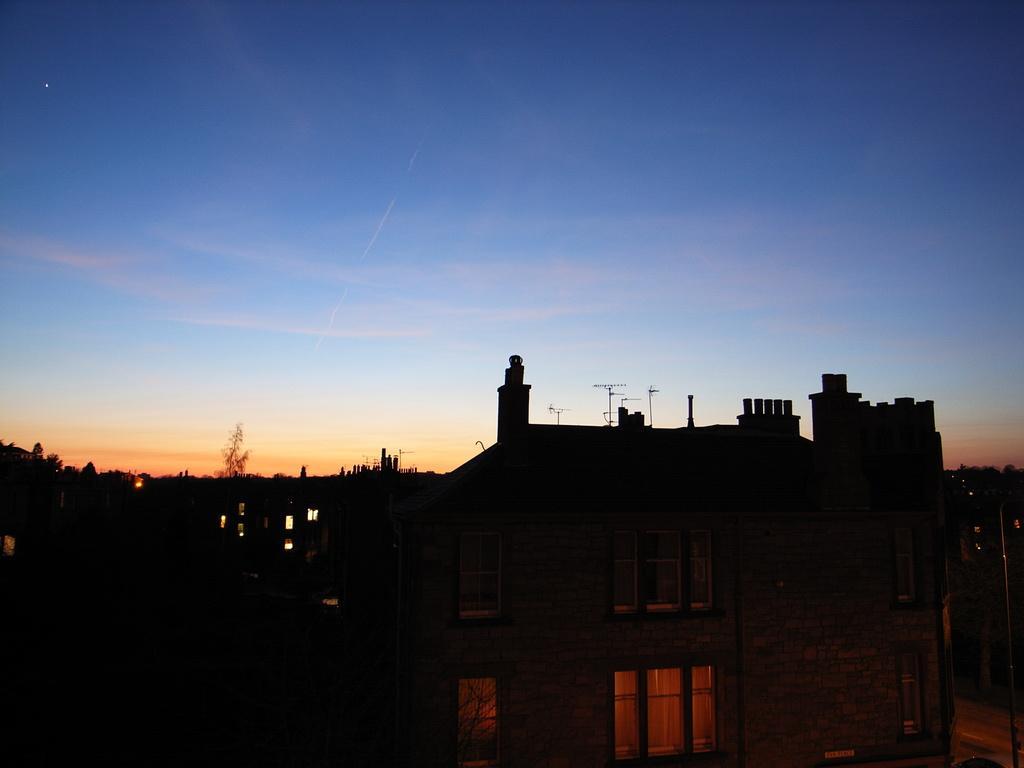In one or two sentences, can you explain what this image depicts? In this image, I can see the buildings and trees. In the background, there is the sky. 